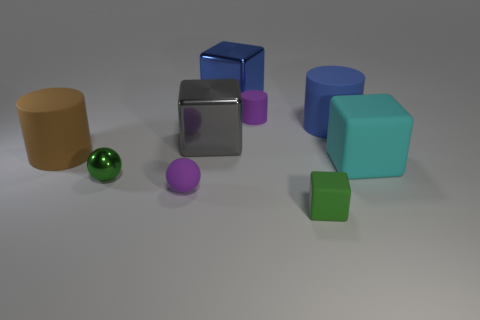Add 1 gray objects. How many objects exist? 10 Subtract all big rubber cylinders. How many cylinders are left? 1 Subtract all gray cubes. How many cubes are left? 3 Add 1 small things. How many small things are left? 5 Add 9 small yellow shiny blocks. How many small yellow shiny blocks exist? 9 Subtract 0 red cylinders. How many objects are left? 9 Subtract all cylinders. How many objects are left? 6 Subtract 4 blocks. How many blocks are left? 0 Subtract all purple cylinders. Subtract all brown spheres. How many cylinders are left? 2 Subtract all gray spheres. How many green cubes are left? 1 